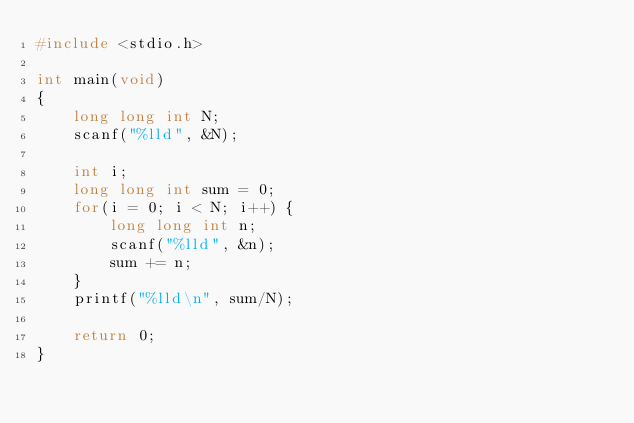<code> <loc_0><loc_0><loc_500><loc_500><_C_>#include <stdio.h>

int main(void)
{
	long long int N;
	scanf("%lld", &N);
	
	int i;
	long long int sum = 0;
	for(i = 0; i < N; i++) {
		long long int n;
		scanf("%lld", &n);
		sum += n;
	}
	printf("%lld\n", sum/N);
	
	return 0;
}
</code> 